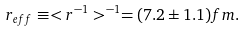<formula> <loc_0><loc_0><loc_500><loc_500>r _ { e f f } \equiv < r ^ { - 1 } > ^ { - 1 } = ( 7 . 2 \pm 1 . 1 ) f m .</formula> 